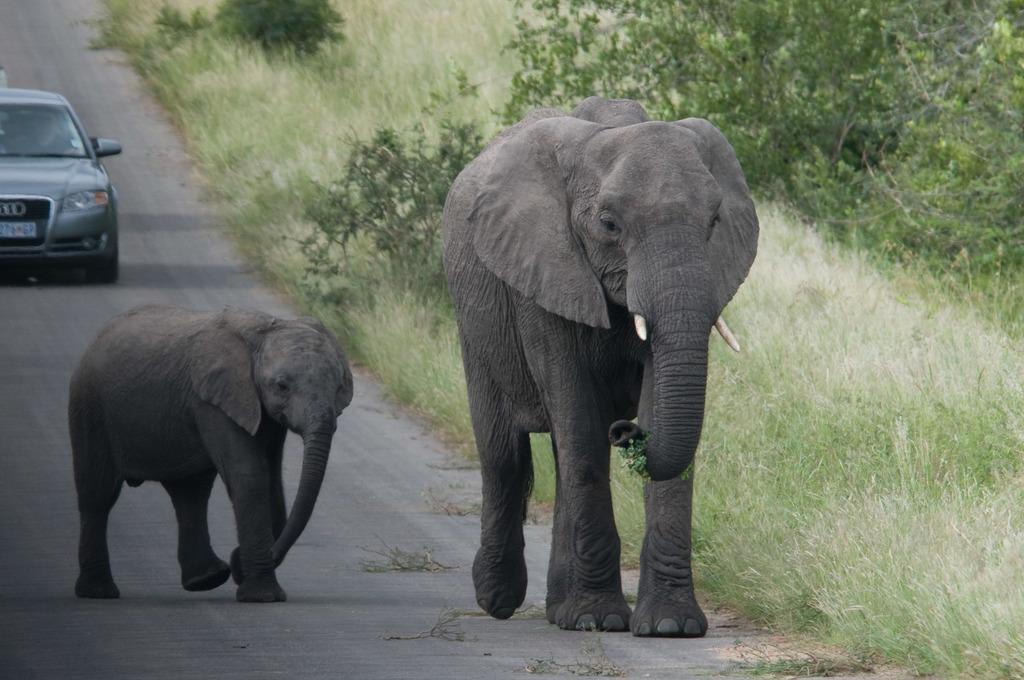Describe this image in one or two sentences. This is an elephant and a baby elephant are walking on the road. Here is a grass. These are the trees and plants. I can see a car on the road. 